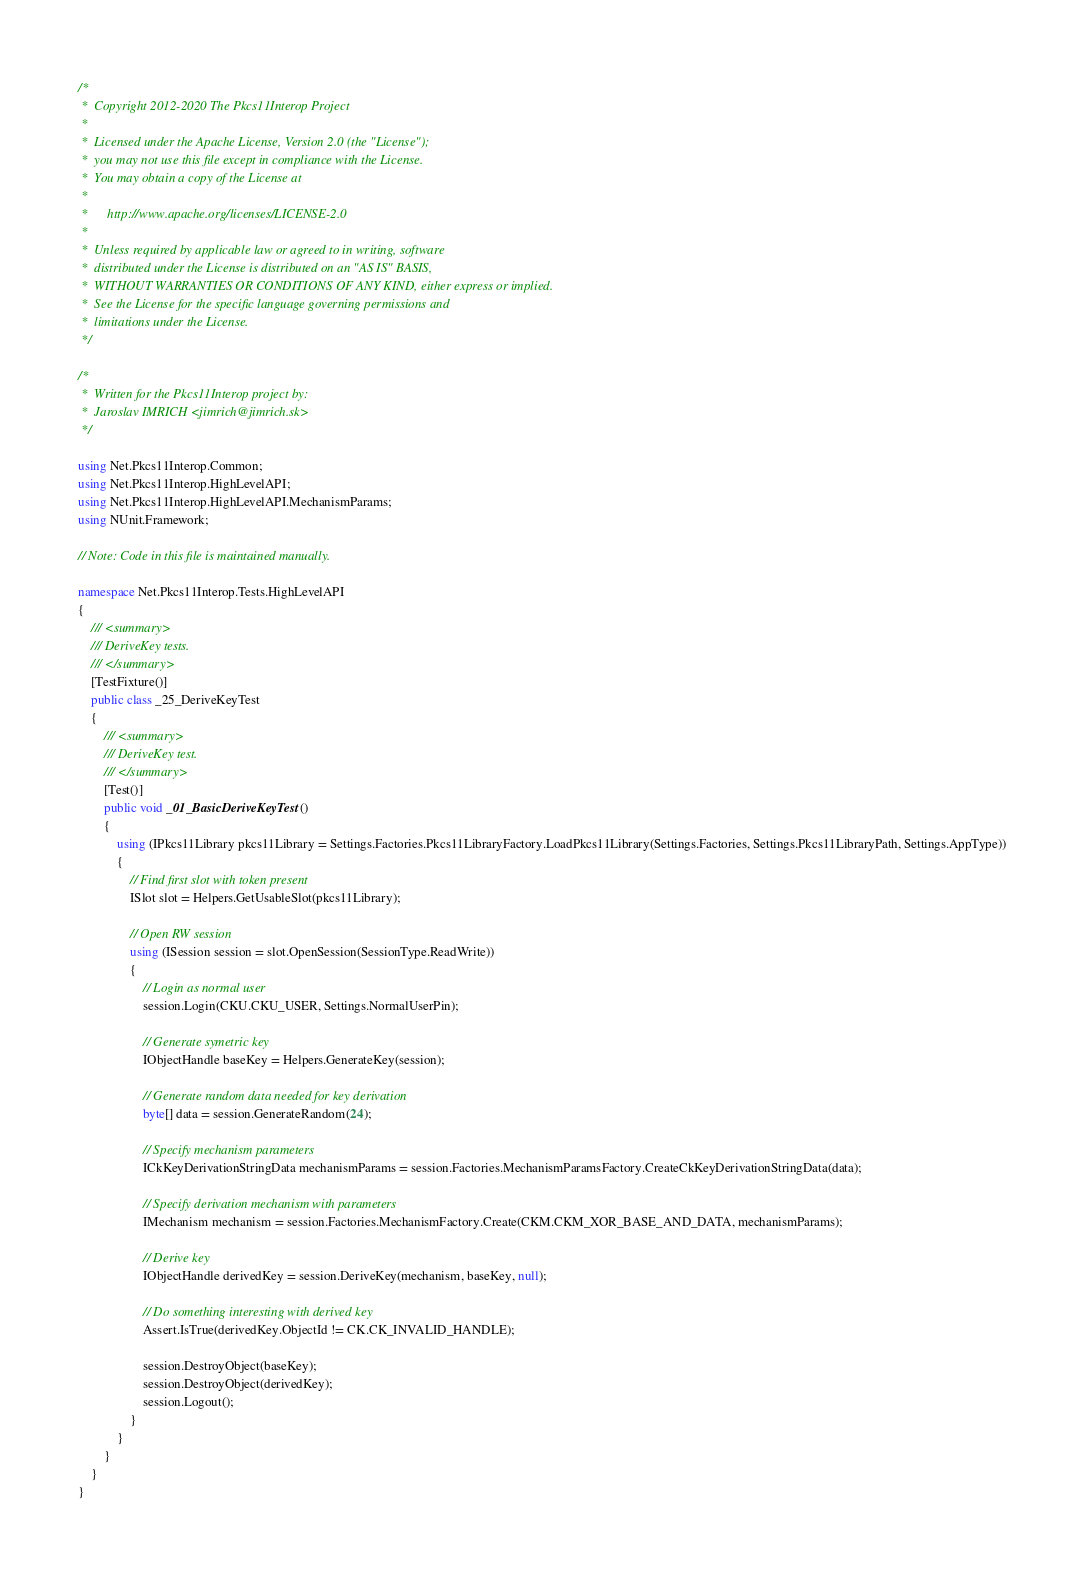Convert code to text. <code><loc_0><loc_0><loc_500><loc_500><_C#_>/*
 *  Copyright 2012-2020 The Pkcs11Interop Project
 *
 *  Licensed under the Apache License, Version 2.0 (the "License");
 *  you may not use this file except in compliance with the License.
 *  You may obtain a copy of the License at
 *
 *      http://www.apache.org/licenses/LICENSE-2.0
 *
 *  Unless required by applicable law or agreed to in writing, software
 *  distributed under the License is distributed on an "AS IS" BASIS,
 *  WITHOUT WARRANTIES OR CONDITIONS OF ANY KIND, either express or implied.
 *  See the License for the specific language governing permissions and
 *  limitations under the License.
 */

/*
 *  Written for the Pkcs11Interop project by:
 *  Jaroslav IMRICH <jimrich@jimrich.sk>
 */

using Net.Pkcs11Interop.Common;
using Net.Pkcs11Interop.HighLevelAPI;
using Net.Pkcs11Interop.HighLevelAPI.MechanismParams;
using NUnit.Framework;

// Note: Code in this file is maintained manually.

namespace Net.Pkcs11Interop.Tests.HighLevelAPI
{
    /// <summary>
    /// DeriveKey tests.
    /// </summary>
    [TestFixture()]
    public class _25_DeriveKeyTest
    {
        /// <summary>
        /// DeriveKey test.
        /// </summary>
        [Test()]
        public void _01_BasicDeriveKeyTest()
        {
            using (IPkcs11Library pkcs11Library = Settings.Factories.Pkcs11LibraryFactory.LoadPkcs11Library(Settings.Factories, Settings.Pkcs11LibraryPath, Settings.AppType))
            {
                // Find first slot with token present
                ISlot slot = Helpers.GetUsableSlot(pkcs11Library);
                
                // Open RW session
                using (ISession session = slot.OpenSession(SessionType.ReadWrite))
                {
                    // Login as normal user
                    session.Login(CKU.CKU_USER, Settings.NormalUserPin);
                    
                    // Generate symetric key
                    IObjectHandle baseKey = Helpers.GenerateKey(session);

                    // Generate random data needed for key derivation
                    byte[] data = session.GenerateRandom(24);

                    // Specify mechanism parameters
                    ICkKeyDerivationStringData mechanismParams = session.Factories.MechanismParamsFactory.CreateCkKeyDerivationStringData(data);

                    // Specify derivation mechanism with parameters
                    IMechanism mechanism = session.Factories.MechanismFactory.Create(CKM.CKM_XOR_BASE_AND_DATA, mechanismParams);
                    
                    // Derive key
                    IObjectHandle derivedKey = session.DeriveKey(mechanism, baseKey, null);

                    // Do something interesting with derived key
                    Assert.IsTrue(derivedKey.ObjectId != CK.CK_INVALID_HANDLE);

                    session.DestroyObject(baseKey);
                    session.DestroyObject(derivedKey);
                    session.Logout();
                }
            }
        }
    }
}
</code> 